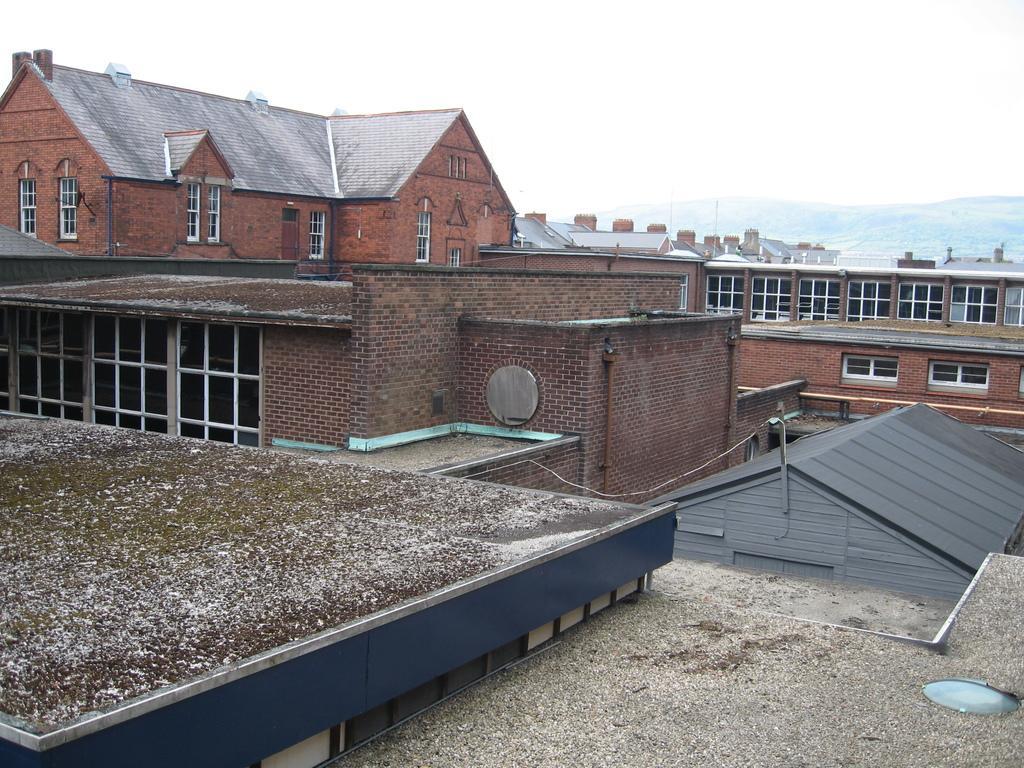Can you describe this image briefly? In this image we can see the buildings. And we can see the windows. And we can see the hill and the sky. 